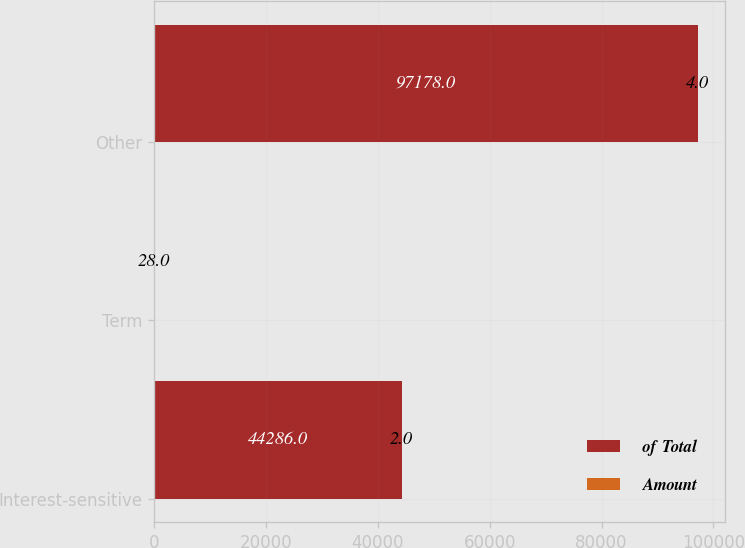<chart> <loc_0><loc_0><loc_500><loc_500><stacked_bar_chart><ecel><fcel>Interest-sensitive<fcel>Term<fcel>Other<nl><fcel>of Total<fcel>44286<fcel>28<fcel>97178<nl><fcel>Amount<fcel>2<fcel>28<fcel>4<nl></chart> 